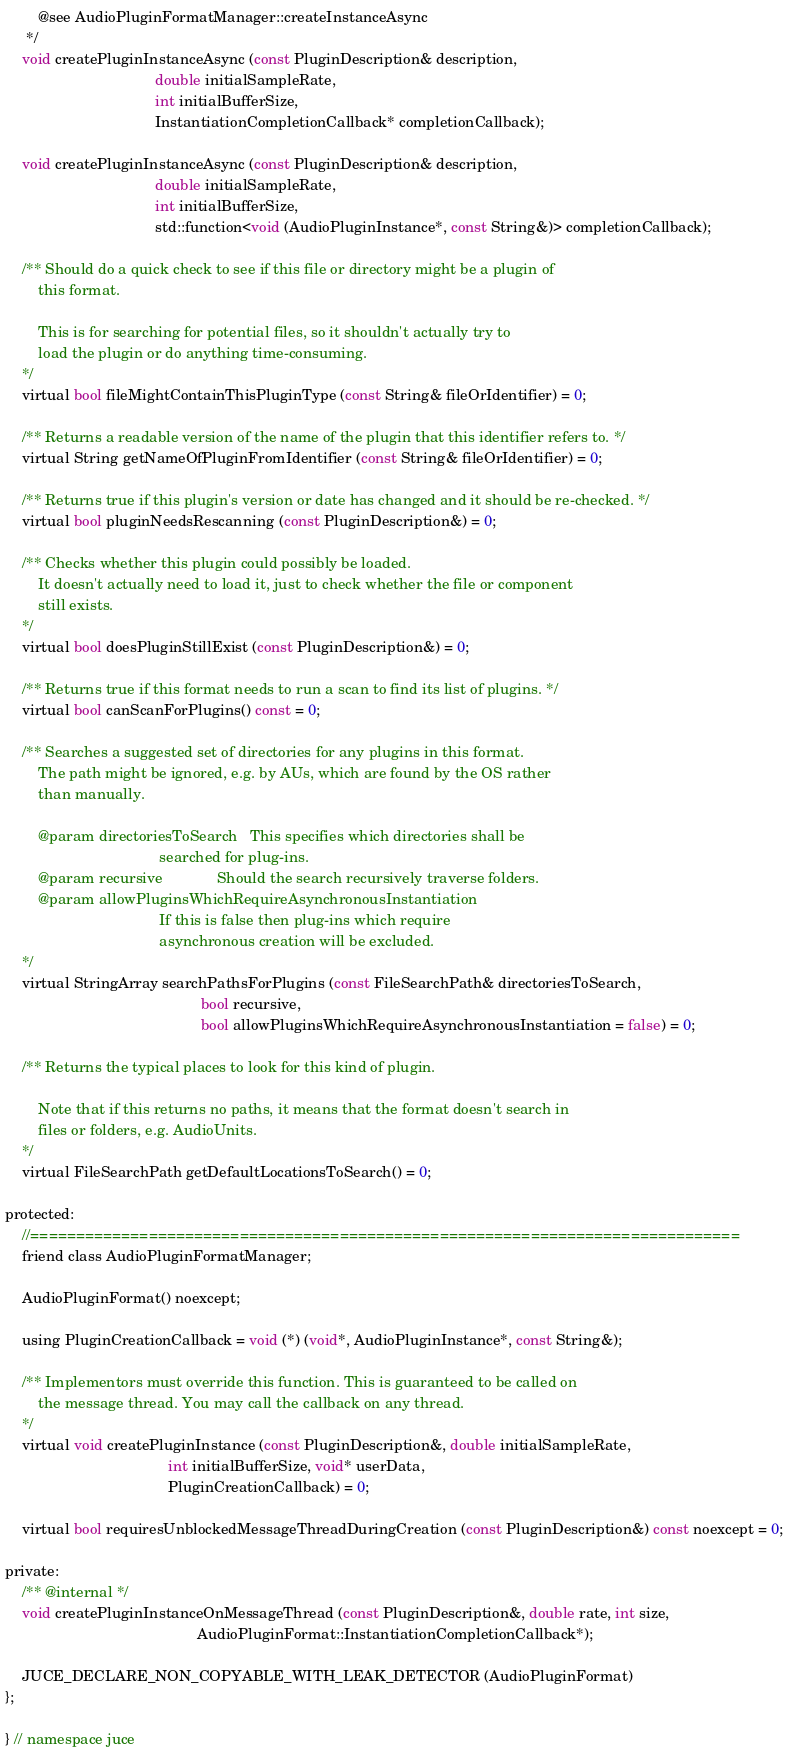<code> <loc_0><loc_0><loc_500><loc_500><_C_>        @see AudioPluginFormatManager::createInstanceAsync
     */
    void createPluginInstanceAsync (const PluginDescription& description,
                                    double initialSampleRate,
                                    int initialBufferSize,
                                    InstantiationCompletionCallback* completionCallback);

    void createPluginInstanceAsync (const PluginDescription& description,
                                    double initialSampleRate,
                                    int initialBufferSize,
                                    std::function<void (AudioPluginInstance*, const String&)> completionCallback);

    /** Should do a quick check to see if this file or directory might be a plugin of
        this format.

        This is for searching for potential files, so it shouldn't actually try to
        load the plugin or do anything time-consuming.
    */
    virtual bool fileMightContainThisPluginType (const String& fileOrIdentifier) = 0;

    /** Returns a readable version of the name of the plugin that this identifier refers to. */
    virtual String getNameOfPluginFromIdentifier (const String& fileOrIdentifier) = 0;

    /** Returns true if this plugin's version or date has changed and it should be re-checked. */
    virtual bool pluginNeedsRescanning (const PluginDescription&) = 0;

    /** Checks whether this plugin could possibly be loaded.
        It doesn't actually need to load it, just to check whether the file or component
        still exists.
    */
    virtual bool doesPluginStillExist (const PluginDescription&) = 0;

    /** Returns true if this format needs to run a scan to find its list of plugins. */
    virtual bool canScanForPlugins() const = 0;

    /** Searches a suggested set of directories for any plugins in this format.
        The path might be ignored, e.g. by AUs, which are found by the OS rather
        than manually.

        @param directoriesToSearch   This specifies which directories shall be
                                     searched for plug-ins.
        @param recursive             Should the search recursively traverse folders.
        @param allowPluginsWhichRequireAsynchronousInstantiation
                                     If this is false then plug-ins which require
                                     asynchronous creation will be excluded.
    */
    virtual StringArray searchPathsForPlugins (const FileSearchPath& directoriesToSearch,
                                               bool recursive,
                                               bool allowPluginsWhichRequireAsynchronousInstantiation = false) = 0;

    /** Returns the typical places to look for this kind of plugin.

        Note that if this returns no paths, it means that the format doesn't search in
        files or folders, e.g. AudioUnits.
    */
    virtual FileSearchPath getDefaultLocationsToSearch() = 0;

protected:
    //==============================================================================
    friend class AudioPluginFormatManager;

    AudioPluginFormat() noexcept;

    using PluginCreationCallback = void (*) (void*, AudioPluginInstance*, const String&);

    /** Implementors must override this function. This is guaranteed to be called on
        the message thread. You may call the callback on any thread.
    */
    virtual void createPluginInstance (const PluginDescription&, double initialSampleRate,
                                       int initialBufferSize, void* userData,
                                       PluginCreationCallback) = 0;

    virtual bool requiresUnblockedMessageThreadDuringCreation (const PluginDescription&) const noexcept = 0;

private:
    /** @internal */
    void createPluginInstanceOnMessageThread (const PluginDescription&, double rate, int size,
                                              AudioPluginFormat::InstantiationCompletionCallback*);

    JUCE_DECLARE_NON_COPYABLE_WITH_LEAK_DETECTOR (AudioPluginFormat)
};

} // namespace juce
</code> 